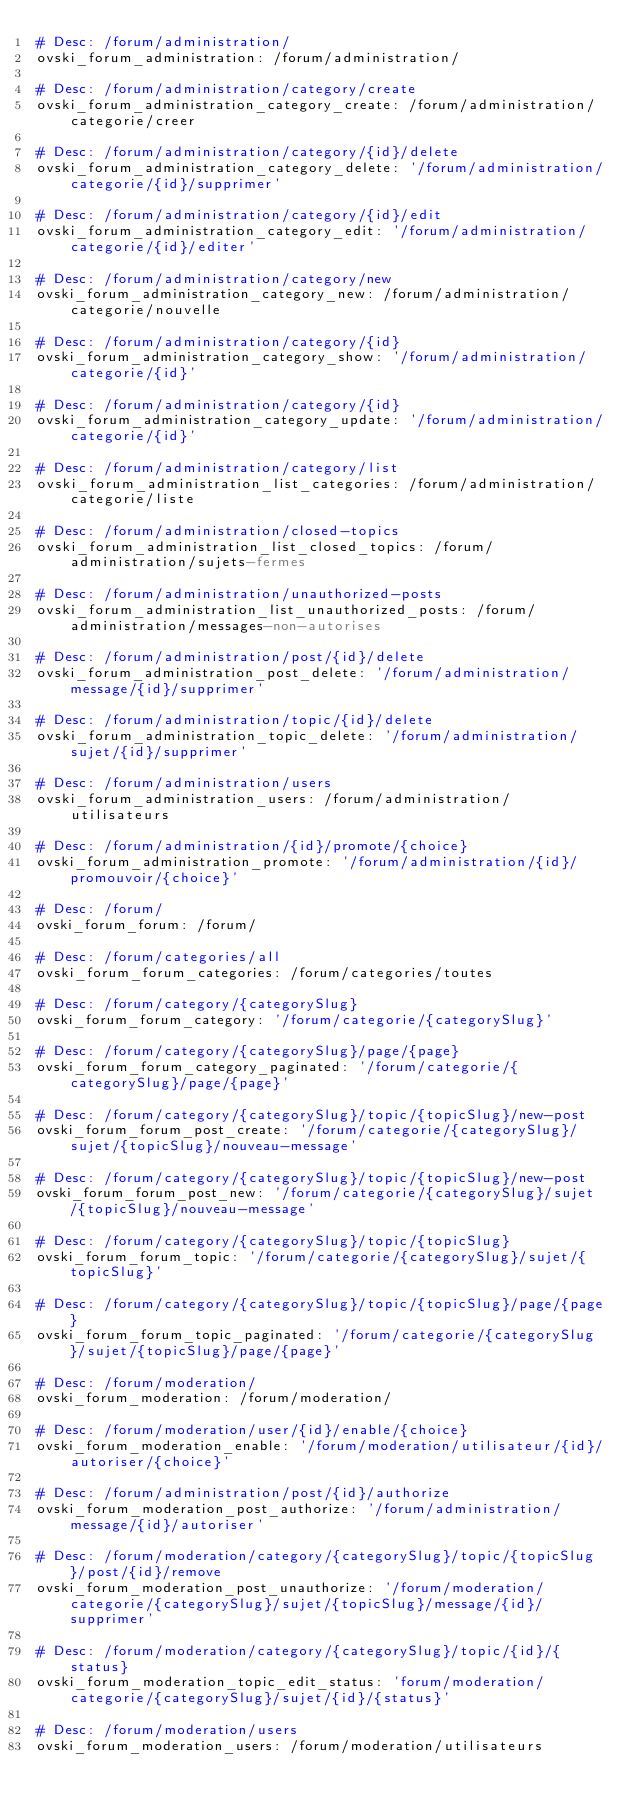Convert code to text. <code><loc_0><loc_0><loc_500><loc_500><_YAML_># Desc: /forum/administration/
ovski_forum_administration: /forum/administration/

# Desc: /forum/administration/category/create
ovski_forum_administration_category_create: /forum/administration/categorie/creer

# Desc: /forum/administration/category/{id}/delete
ovski_forum_administration_category_delete: '/forum/administration/categorie/{id}/supprimer'

# Desc: /forum/administration/category/{id}/edit
ovski_forum_administration_category_edit: '/forum/administration/categorie/{id}/editer'

# Desc: /forum/administration/category/new
ovski_forum_administration_category_new: /forum/administration/categorie/nouvelle

# Desc: /forum/administration/category/{id}
ovski_forum_administration_category_show: '/forum/administration/categorie/{id}'

# Desc: /forum/administration/category/{id}
ovski_forum_administration_category_update: '/forum/administration/categorie/{id}'

# Desc: /forum/administration/category/list
ovski_forum_administration_list_categories: /forum/administration/categorie/liste

# Desc: /forum/administration/closed-topics
ovski_forum_administration_list_closed_topics: /forum/administration/sujets-fermes

# Desc: /forum/administration/unauthorized-posts
ovski_forum_administration_list_unauthorized_posts: /forum/administration/messages-non-autorises

# Desc: /forum/administration/post/{id}/delete
ovski_forum_administration_post_delete: '/forum/administration/message/{id}/supprimer'

# Desc: /forum/administration/topic/{id}/delete
ovski_forum_administration_topic_delete: '/forum/administration/sujet/{id}/supprimer'

# Desc: /forum/administration/users
ovski_forum_administration_users: /forum/administration/utilisateurs

# Desc: /forum/administration/{id}/promote/{choice}
ovski_forum_administration_promote: '/forum/administration/{id}/promouvoir/{choice}'

# Desc: /forum/
ovski_forum_forum: /forum/

# Desc: /forum/categories/all
ovski_forum_forum_categories: /forum/categories/toutes

# Desc: /forum/category/{categorySlug}
ovski_forum_forum_category: '/forum/categorie/{categorySlug}'

# Desc: /forum/category/{categorySlug}/page/{page}
ovski_forum_forum_category_paginated: '/forum/categorie/{categorySlug}/page/{page}'

# Desc: /forum/category/{categorySlug}/topic/{topicSlug}/new-post
ovski_forum_forum_post_create: '/forum/categorie/{categorySlug}/sujet/{topicSlug}/nouveau-message'

# Desc: /forum/category/{categorySlug}/topic/{topicSlug}/new-post
ovski_forum_forum_post_new: '/forum/categorie/{categorySlug}/sujet/{topicSlug}/nouveau-message'

# Desc: /forum/category/{categorySlug}/topic/{topicSlug}
ovski_forum_forum_topic: '/forum/categorie/{categorySlug}/sujet/{topicSlug}'

# Desc: /forum/category/{categorySlug}/topic/{topicSlug}/page/{page}
ovski_forum_forum_topic_paginated: '/forum/categorie/{categorySlug}/sujet/{topicSlug}/page/{page}'

# Desc: /forum/moderation/
ovski_forum_moderation: /forum/moderation/

# Desc: /forum/moderation/user/{id}/enable/{choice}
ovski_forum_moderation_enable: '/forum/moderation/utilisateur/{id}/autoriser/{choice}'

# Desc: /forum/administration/post/{id}/authorize
ovski_forum_moderation_post_authorize: '/forum/administration/message/{id}/autoriser'

# Desc: /forum/moderation/category/{categorySlug}/topic/{topicSlug}/post/{id}/remove
ovski_forum_moderation_post_unauthorize: '/forum/moderation/categorie/{categorySlug}/sujet/{topicSlug}/message/{id}/supprimer'

# Desc: /forum/moderation/category/{categorySlug}/topic/{id}/{status}
ovski_forum_moderation_topic_edit_status: 'forum/moderation/categorie/{categorySlug}/sujet/{id}/{status}'

# Desc: /forum/moderation/users
ovski_forum_moderation_users: /forum/moderation/utilisateurs
</code> 